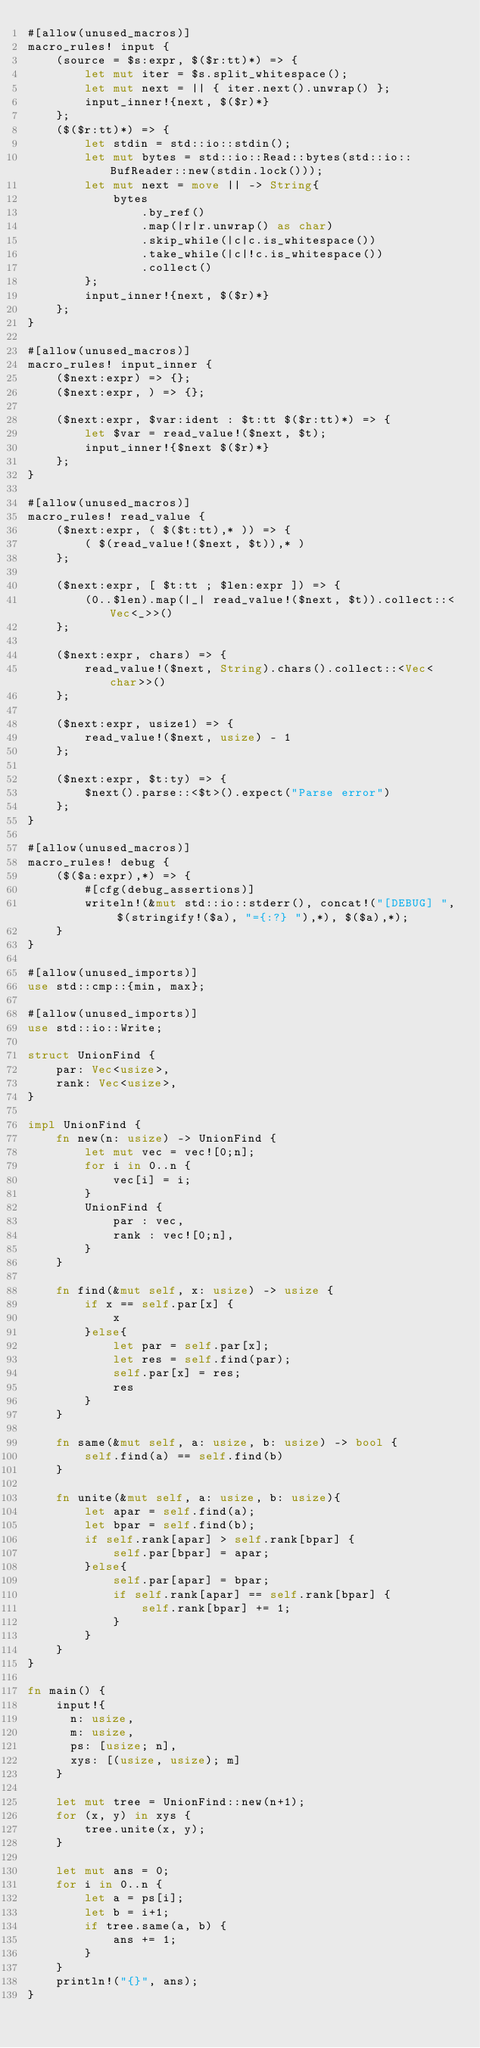Convert code to text. <code><loc_0><loc_0><loc_500><loc_500><_Rust_>#[allow(unused_macros)]
macro_rules! input {
    (source = $s:expr, $($r:tt)*) => {
        let mut iter = $s.split_whitespace();
        let mut next = || { iter.next().unwrap() };
        input_inner!{next, $($r)*}
    };
    ($($r:tt)*) => {
        let stdin = std::io::stdin();
        let mut bytes = std::io::Read::bytes(std::io::BufReader::new(stdin.lock()));
        let mut next = move || -> String{
            bytes
                .by_ref()
                .map(|r|r.unwrap() as char)
                .skip_while(|c|c.is_whitespace())
                .take_while(|c|!c.is_whitespace())
                .collect()
        };
        input_inner!{next, $($r)*}
    };
}

#[allow(unused_macros)]
macro_rules! input_inner {
    ($next:expr) => {};
    ($next:expr, ) => {};

    ($next:expr, $var:ident : $t:tt $($r:tt)*) => {
        let $var = read_value!($next, $t);
        input_inner!{$next $($r)*}
    };
}

#[allow(unused_macros)]
macro_rules! read_value {
    ($next:expr, ( $($t:tt),* )) => {
        ( $(read_value!($next, $t)),* )
    };

    ($next:expr, [ $t:tt ; $len:expr ]) => {
        (0..$len).map(|_| read_value!($next, $t)).collect::<Vec<_>>()
    };

    ($next:expr, chars) => {
        read_value!($next, String).chars().collect::<Vec<char>>()
    };

    ($next:expr, usize1) => {
        read_value!($next, usize) - 1
    };

    ($next:expr, $t:ty) => {
        $next().parse::<$t>().expect("Parse error")
    };
}

#[allow(unused_macros)]
macro_rules! debug {
    ($($a:expr),*) => {
        #[cfg(debug_assertions)]
        writeln!(&mut std::io::stderr(), concat!("[DEBUG] ", $(stringify!($a), "={:?} "),*), $($a),*);
    }
}

#[allow(unused_imports)]
use std::cmp::{min, max};

#[allow(unused_imports)]
use std::io::Write;

struct UnionFind {
    par: Vec<usize>,
    rank: Vec<usize>,
}

impl UnionFind {
    fn new(n: usize) -> UnionFind {
        let mut vec = vec![0;n];
        for i in 0..n {
            vec[i] = i;
        }
        UnionFind {
            par : vec,
            rank : vec![0;n],
        }
    }

    fn find(&mut self, x: usize) -> usize {
        if x == self.par[x] {
            x
        }else{
            let par = self.par[x];
            let res = self.find(par);
            self.par[x] = res;
            res
        }
    }

    fn same(&mut self, a: usize, b: usize) -> bool {
        self.find(a) == self.find(b)
    }

    fn unite(&mut self, a: usize, b: usize){
        let apar = self.find(a);
        let bpar = self.find(b);
        if self.rank[apar] > self.rank[bpar] {
            self.par[bpar] = apar;
        }else{
            self.par[apar] = bpar;
            if self.rank[apar] == self.rank[bpar] {
                self.rank[bpar] += 1;
            }
        }
    }
}

fn main() {
    input!{
      n: usize,
      m: usize,
      ps: [usize; n],
      xys: [(usize, usize); m]
    }

    let mut tree = UnionFind::new(n+1);
    for (x, y) in xys {
        tree.unite(x, y);
    }

    let mut ans = 0;
    for i in 0..n {
        let a = ps[i];
        let b = i+1;
        if tree.same(a, b) {
            ans += 1;
        }
    }
    println!("{}", ans);
}
</code> 